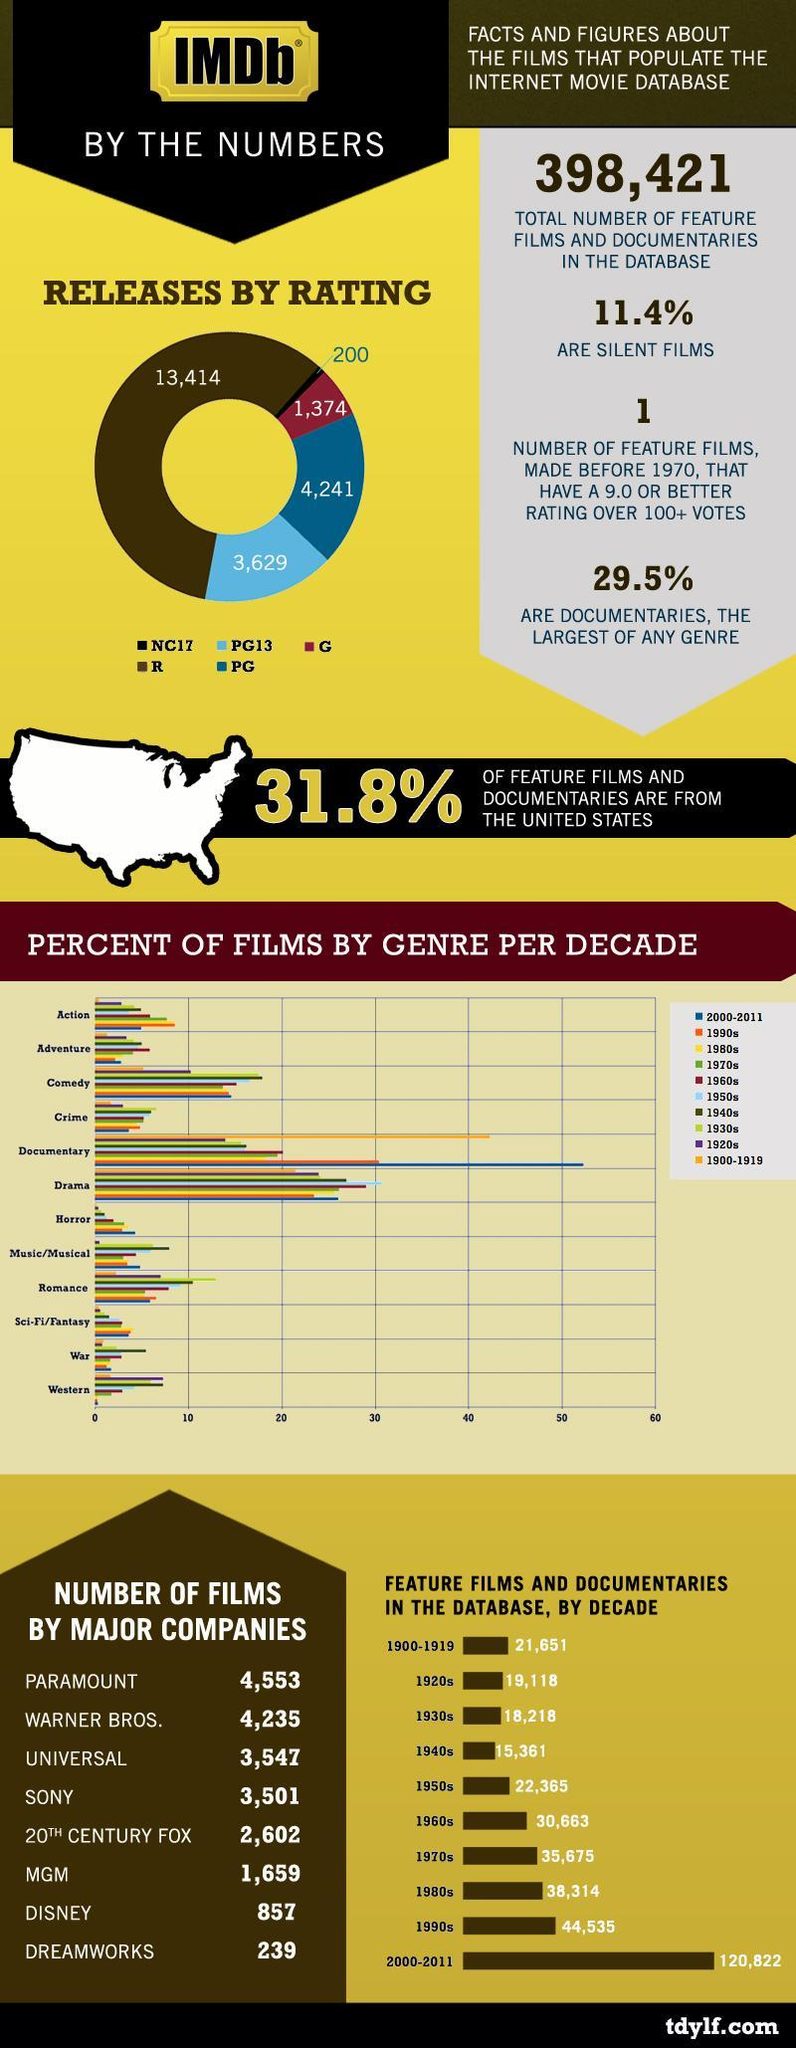For which decade has the highest no of dramatic movies?
Answer the question with a short phrase. 1950s How many films released on the internet wherein the rating NC17? 200 How many movies been released on the internet with ratings restricted? 13,414 For which decade has the highest no of horror movies? 2000-2011 How many films released on the internet wherein the rating PG? 4,241 Which decade ranks third position in the no of feature films and documentaries? 1980s Which genre movies were more in the period 2000-2011? Documentary How many films were released on the internet with a rating G? 1,374 In 1990 what genre of movies was more released? Documentary How many films were done by Disney and MGM took together? 2,516 